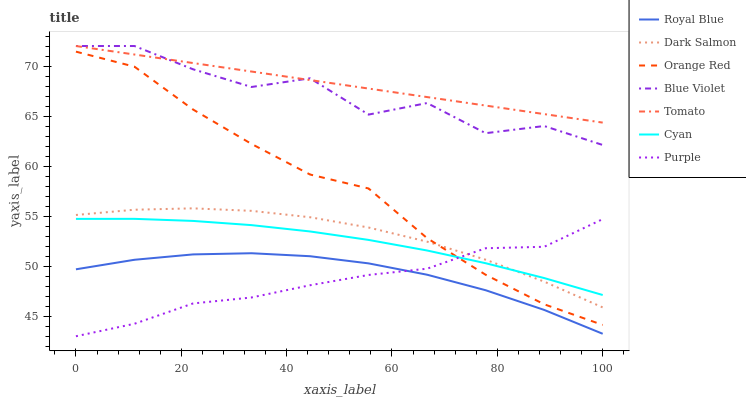Does Purple have the minimum area under the curve?
Answer yes or no. Yes. Does Tomato have the maximum area under the curve?
Answer yes or no. Yes. Does Dark Salmon have the minimum area under the curve?
Answer yes or no. No. Does Dark Salmon have the maximum area under the curve?
Answer yes or no. No. Is Tomato the smoothest?
Answer yes or no. Yes. Is Blue Violet the roughest?
Answer yes or no. Yes. Is Purple the smoothest?
Answer yes or no. No. Is Purple the roughest?
Answer yes or no. No. Does Purple have the lowest value?
Answer yes or no. Yes. Does Dark Salmon have the lowest value?
Answer yes or no. No. Does Blue Violet have the highest value?
Answer yes or no. Yes. Does Purple have the highest value?
Answer yes or no. No. Is Purple less than Blue Violet?
Answer yes or no. Yes. Is Tomato greater than Dark Salmon?
Answer yes or no. Yes. Does Blue Violet intersect Tomato?
Answer yes or no. Yes. Is Blue Violet less than Tomato?
Answer yes or no. No. Is Blue Violet greater than Tomato?
Answer yes or no. No. Does Purple intersect Blue Violet?
Answer yes or no. No. 